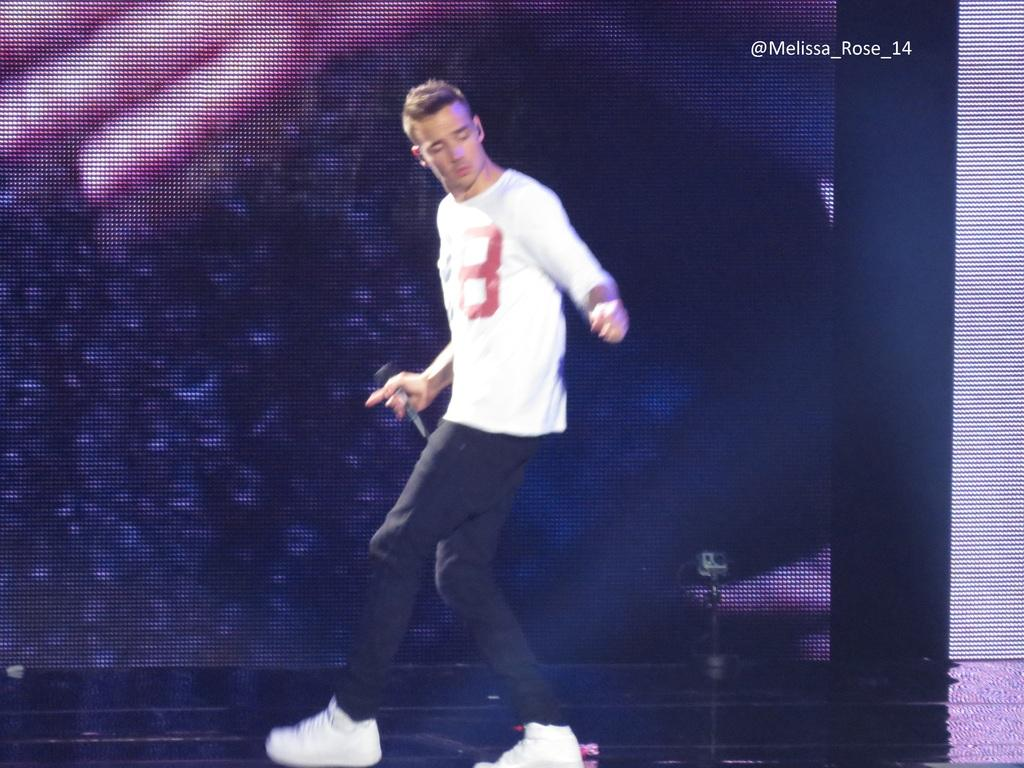Who or what is the main subject in the image? There is a person in the image. What is the person holding in the image? The person is holding a mic. Can you describe the person's attire in the image? The person is wearing a black and white color dress. What can be seen in the background of the image? There is a colorful screen visible in the background. What type of kettle is visible on the person's head in the image? There is no kettle visible on the person's head in the image. What emotion does the person seem to be expressing while holding the mic? The provided facts do not mention the person's emotions or expressions, so we cannot determine their emotional state from the image. 